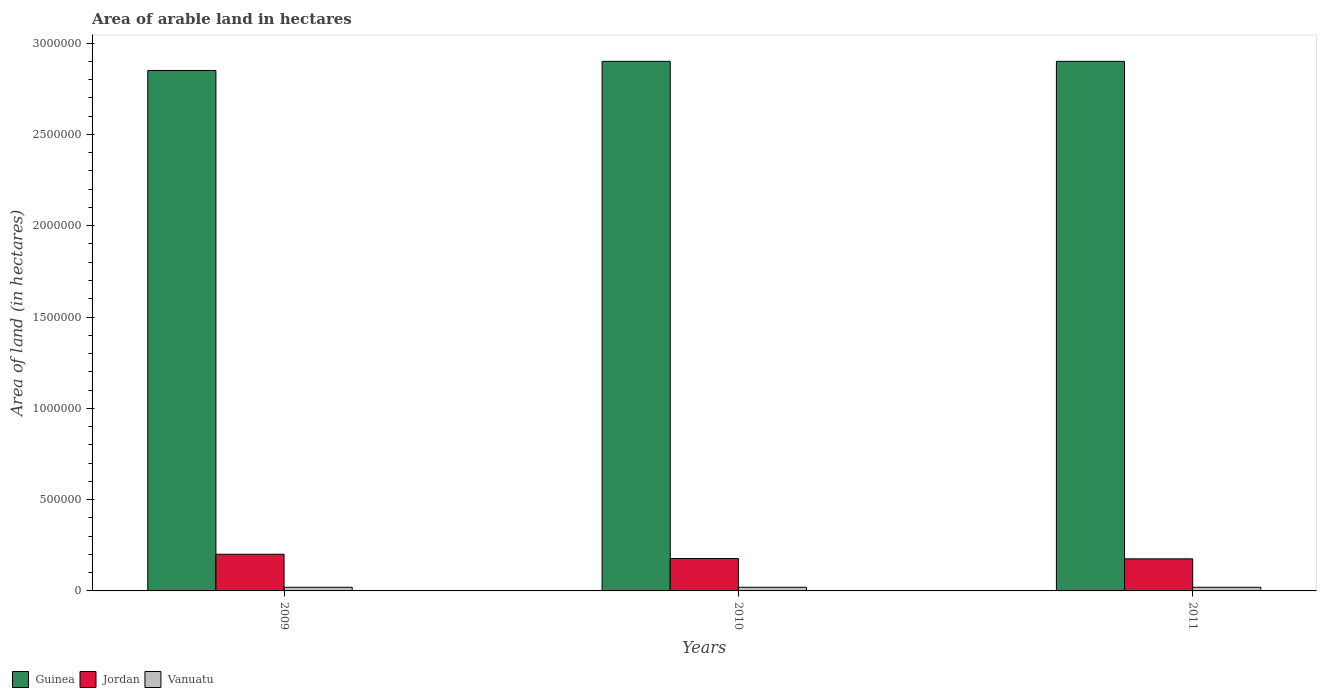How many bars are there on the 1st tick from the right?
Your response must be concise. 3. What is the label of the 2nd group of bars from the left?
Your response must be concise. 2010. What is the total arable land in Guinea in 2010?
Ensure brevity in your answer.  2.90e+06. Across all years, what is the maximum total arable land in Vanuatu?
Provide a short and direct response. 2.00e+04. Across all years, what is the minimum total arable land in Vanuatu?
Make the answer very short. 2.00e+04. What is the total total arable land in Vanuatu in the graph?
Provide a succinct answer. 6.00e+04. What is the difference between the total arable land in Guinea in 2010 and that in 2011?
Offer a very short reply. 0. What is the difference between the total arable land in Guinea in 2011 and the total arable land in Vanuatu in 2009?
Make the answer very short. 2.88e+06. What is the average total arable land in Vanuatu per year?
Offer a terse response. 2.00e+04. In the year 2009, what is the difference between the total arable land in Jordan and total arable land in Guinea?
Your answer should be compact. -2.65e+06. What is the ratio of the total arable land in Jordan in 2009 to that in 2011?
Provide a short and direct response. 1.14. Is the difference between the total arable land in Jordan in 2009 and 2010 greater than the difference between the total arable land in Guinea in 2009 and 2010?
Make the answer very short. Yes. What is the difference between the highest and the lowest total arable land in Vanuatu?
Offer a very short reply. 0. What does the 3rd bar from the left in 2011 represents?
Provide a short and direct response. Vanuatu. What does the 3rd bar from the right in 2010 represents?
Keep it short and to the point. Guinea. Are all the bars in the graph horizontal?
Keep it short and to the point. No. How many years are there in the graph?
Your answer should be compact. 3. Does the graph contain grids?
Your response must be concise. No. What is the title of the graph?
Keep it short and to the point. Area of arable land in hectares. Does "Middle East & North Africa (developing only)" appear as one of the legend labels in the graph?
Give a very brief answer. No. What is the label or title of the X-axis?
Provide a short and direct response. Years. What is the label or title of the Y-axis?
Offer a very short reply. Area of land (in hectares). What is the Area of land (in hectares) of Guinea in 2009?
Provide a succinct answer. 2.85e+06. What is the Area of land (in hectares) of Jordan in 2009?
Offer a terse response. 2.01e+05. What is the Area of land (in hectares) in Guinea in 2010?
Your answer should be very brief. 2.90e+06. What is the Area of land (in hectares) of Jordan in 2010?
Give a very brief answer. 1.78e+05. What is the Area of land (in hectares) of Guinea in 2011?
Ensure brevity in your answer.  2.90e+06. What is the Area of land (in hectares) of Jordan in 2011?
Your answer should be very brief. 1.76e+05. Across all years, what is the maximum Area of land (in hectares) of Guinea?
Provide a short and direct response. 2.90e+06. Across all years, what is the maximum Area of land (in hectares) of Jordan?
Make the answer very short. 2.01e+05. Across all years, what is the minimum Area of land (in hectares) of Guinea?
Ensure brevity in your answer.  2.85e+06. Across all years, what is the minimum Area of land (in hectares) in Jordan?
Give a very brief answer. 1.76e+05. What is the total Area of land (in hectares) of Guinea in the graph?
Your answer should be very brief. 8.65e+06. What is the total Area of land (in hectares) in Jordan in the graph?
Provide a short and direct response. 5.54e+05. What is the difference between the Area of land (in hectares) of Guinea in 2009 and that in 2010?
Offer a very short reply. -5.00e+04. What is the difference between the Area of land (in hectares) in Jordan in 2009 and that in 2010?
Offer a very short reply. 2.32e+04. What is the difference between the Area of land (in hectares) in Vanuatu in 2009 and that in 2010?
Make the answer very short. 0. What is the difference between the Area of land (in hectares) in Guinea in 2009 and that in 2011?
Provide a short and direct response. -5.00e+04. What is the difference between the Area of land (in hectares) of Jordan in 2009 and that in 2011?
Ensure brevity in your answer.  2.52e+04. What is the difference between the Area of land (in hectares) in Vanuatu in 2009 and that in 2011?
Provide a short and direct response. 0. What is the difference between the Area of land (in hectares) in Guinea in 2010 and that in 2011?
Your answer should be very brief. 0. What is the difference between the Area of land (in hectares) in Vanuatu in 2010 and that in 2011?
Ensure brevity in your answer.  0. What is the difference between the Area of land (in hectares) of Guinea in 2009 and the Area of land (in hectares) of Jordan in 2010?
Give a very brief answer. 2.67e+06. What is the difference between the Area of land (in hectares) of Guinea in 2009 and the Area of land (in hectares) of Vanuatu in 2010?
Your response must be concise. 2.83e+06. What is the difference between the Area of land (in hectares) in Jordan in 2009 and the Area of land (in hectares) in Vanuatu in 2010?
Your answer should be very brief. 1.81e+05. What is the difference between the Area of land (in hectares) in Guinea in 2009 and the Area of land (in hectares) in Jordan in 2011?
Offer a terse response. 2.67e+06. What is the difference between the Area of land (in hectares) in Guinea in 2009 and the Area of land (in hectares) in Vanuatu in 2011?
Keep it short and to the point. 2.83e+06. What is the difference between the Area of land (in hectares) of Jordan in 2009 and the Area of land (in hectares) of Vanuatu in 2011?
Offer a terse response. 1.81e+05. What is the difference between the Area of land (in hectares) of Guinea in 2010 and the Area of land (in hectares) of Jordan in 2011?
Ensure brevity in your answer.  2.72e+06. What is the difference between the Area of land (in hectares) in Guinea in 2010 and the Area of land (in hectares) in Vanuatu in 2011?
Make the answer very short. 2.88e+06. What is the difference between the Area of land (in hectares) of Jordan in 2010 and the Area of land (in hectares) of Vanuatu in 2011?
Give a very brief answer. 1.58e+05. What is the average Area of land (in hectares) in Guinea per year?
Your answer should be compact. 2.88e+06. What is the average Area of land (in hectares) of Jordan per year?
Your answer should be compact. 1.85e+05. In the year 2009, what is the difference between the Area of land (in hectares) of Guinea and Area of land (in hectares) of Jordan?
Offer a very short reply. 2.65e+06. In the year 2009, what is the difference between the Area of land (in hectares) of Guinea and Area of land (in hectares) of Vanuatu?
Make the answer very short. 2.83e+06. In the year 2009, what is the difference between the Area of land (in hectares) of Jordan and Area of land (in hectares) of Vanuatu?
Offer a terse response. 1.81e+05. In the year 2010, what is the difference between the Area of land (in hectares) of Guinea and Area of land (in hectares) of Jordan?
Provide a succinct answer. 2.72e+06. In the year 2010, what is the difference between the Area of land (in hectares) in Guinea and Area of land (in hectares) in Vanuatu?
Your answer should be very brief. 2.88e+06. In the year 2010, what is the difference between the Area of land (in hectares) in Jordan and Area of land (in hectares) in Vanuatu?
Provide a short and direct response. 1.58e+05. In the year 2011, what is the difference between the Area of land (in hectares) of Guinea and Area of land (in hectares) of Jordan?
Your answer should be compact. 2.72e+06. In the year 2011, what is the difference between the Area of land (in hectares) of Guinea and Area of land (in hectares) of Vanuatu?
Ensure brevity in your answer.  2.88e+06. In the year 2011, what is the difference between the Area of land (in hectares) in Jordan and Area of land (in hectares) in Vanuatu?
Ensure brevity in your answer.  1.56e+05. What is the ratio of the Area of land (in hectares) of Guinea in 2009 to that in 2010?
Keep it short and to the point. 0.98. What is the ratio of the Area of land (in hectares) of Jordan in 2009 to that in 2010?
Provide a succinct answer. 1.13. What is the ratio of the Area of land (in hectares) of Vanuatu in 2009 to that in 2010?
Make the answer very short. 1. What is the ratio of the Area of land (in hectares) of Guinea in 2009 to that in 2011?
Offer a terse response. 0.98. What is the ratio of the Area of land (in hectares) of Jordan in 2009 to that in 2011?
Provide a short and direct response. 1.14. What is the ratio of the Area of land (in hectares) of Jordan in 2010 to that in 2011?
Your response must be concise. 1.01. What is the ratio of the Area of land (in hectares) of Vanuatu in 2010 to that in 2011?
Give a very brief answer. 1. What is the difference between the highest and the second highest Area of land (in hectares) in Jordan?
Your answer should be very brief. 2.32e+04. What is the difference between the highest and the second highest Area of land (in hectares) in Vanuatu?
Make the answer very short. 0. What is the difference between the highest and the lowest Area of land (in hectares) of Jordan?
Your answer should be very brief. 2.52e+04. 